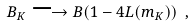Convert formula to latex. <formula><loc_0><loc_0><loc_500><loc_500>B _ { K } \longrightarrow B ( 1 - 4 L ( m _ { K } ) ) \ ,</formula> 